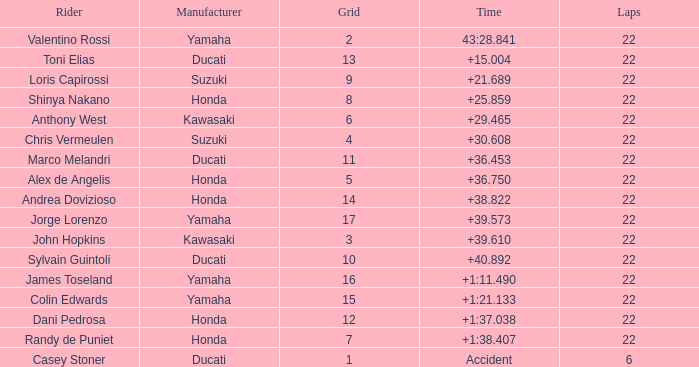What grid is Ducati with fewer than 22 laps? 1.0. 